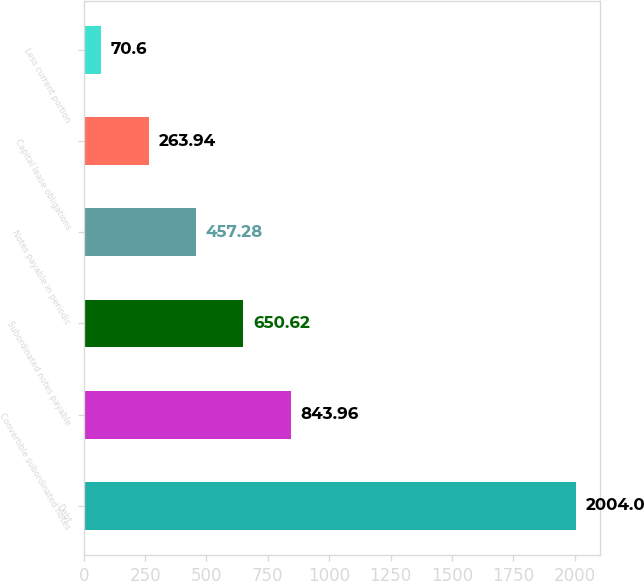Convert chart. <chart><loc_0><loc_0><loc_500><loc_500><bar_chart><fcel>Debt<fcel>Convertible subordinated notes<fcel>Subordinated notes payable<fcel>Notes payable in periodic<fcel>Capital lease obligations<fcel>Less current portion<nl><fcel>2004<fcel>843.96<fcel>650.62<fcel>457.28<fcel>263.94<fcel>70.6<nl></chart> 